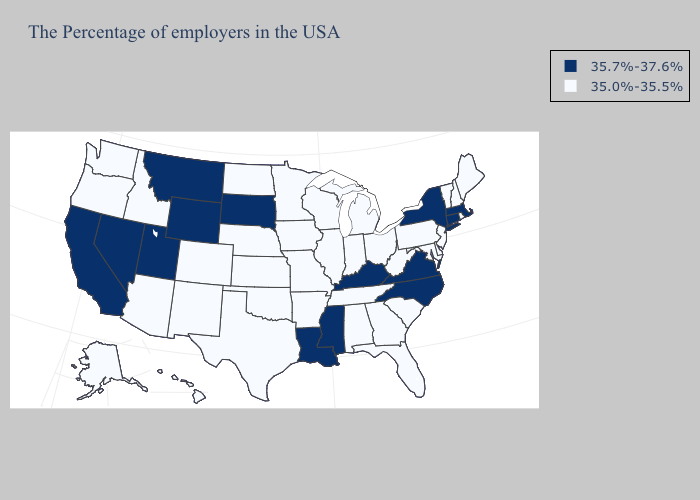Name the states that have a value in the range 35.7%-37.6%?
Answer briefly. Massachusetts, Connecticut, New York, Virginia, North Carolina, Kentucky, Mississippi, Louisiana, South Dakota, Wyoming, Utah, Montana, Nevada, California. Name the states that have a value in the range 35.7%-37.6%?
Be succinct. Massachusetts, Connecticut, New York, Virginia, North Carolina, Kentucky, Mississippi, Louisiana, South Dakota, Wyoming, Utah, Montana, Nevada, California. Name the states that have a value in the range 35.7%-37.6%?
Keep it brief. Massachusetts, Connecticut, New York, Virginia, North Carolina, Kentucky, Mississippi, Louisiana, South Dakota, Wyoming, Utah, Montana, Nevada, California. Among the states that border Washington , which have the lowest value?
Answer briefly. Idaho, Oregon. Which states have the highest value in the USA?
Keep it brief. Massachusetts, Connecticut, New York, Virginia, North Carolina, Kentucky, Mississippi, Louisiana, South Dakota, Wyoming, Utah, Montana, Nevada, California. Name the states that have a value in the range 35.7%-37.6%?
Be succinct. Massachusetts, Connecticut, New York, Virginia, North Carolina, Kentucky, Mississippi, Louisiana, South Dakota, Wyoming, Utah, Montana, Nevada, California. What is the lowest value in the USA?
Be succinct. 35.0%-35.5%. What is the highest value in states that border California?
Concise answer only. 35.7%-37.6%. Name the states that have a value in the range 35.0%-35.5%?
Answer briefly. Maine, Rhode Island, New Hampshire, Vermont, New Jersey, Delaware, Maryland, Pennsylvania, South Carolina, West Virginia, Ohio, Florida, Georgia, Michigan, Indiana, Alabama, Tennessee, Wisconsin, Illinois, Missouri, Arkansas, Minnesota, Iowa, Kansas, Nebraska, Oklahoma, Texas, North Dakota, Colorado, New Mexico, Arizona, Idaho, Washington, Oregon, Alaska, Hawaii. What is the highest value in the USA?
Answer briefly. 35.7%-37.6%. What is the value of Idaho?
Keep it brief. 35.0%-35.5%. What is the value of Wisconsin?
Be succinct. 35.0%-35.5%. Which states have the lowest value in the USA?
Short answer required. Maine, Rhode Island, New Hampshire, Vermont, New Jersey, Delaware, Maryland, Pennsylvania, South Carolina, West Virginia, Ohio, Florida, Georgia, Michigan, Indiana, Alabama, Tennessee, Wisconsin, Illinois, Missouri, Arkansas, Minnesota, Iowa, Kansas, Nebraska, Oklahoma, Texas, North Dakota, Colorado, New Mexico, Arizona, Idaho, Washington, Oregon, Alaska, Hawaii. Name the states that have a value in the range 35.7%-37.6%?
Answer briefly. Massachusetts, Connecticut, New York, Virginia, North Carolina, Kentucky, Mississippi, Louisiana, South Dakota, Wyoming, Utah, Montana, Nevada, California. 